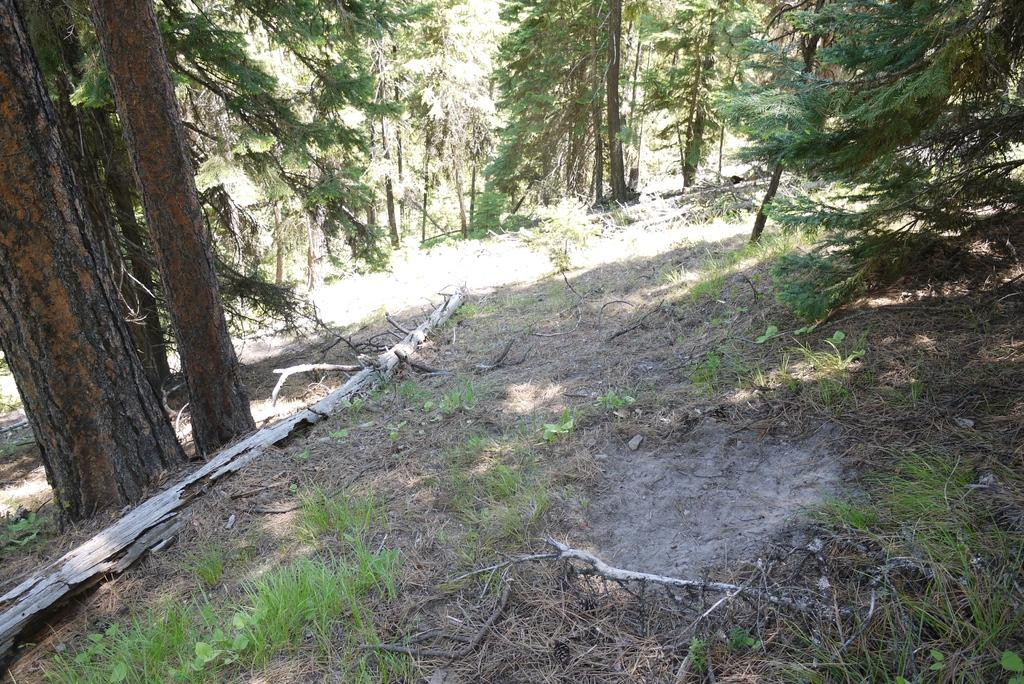What type of vegetation is on the left side of the image? There are trees and grass on the left side of the image. What is located on the left side of the image besides the vegetation? There is a wood on the left side of the image. What type of ground cover is present on both sides of the image? There is grass on the ground on both the left and right sides of the image. What is present on the right side of the image? There is ash on the right side of the image. What type of vegetation is on the right side of the image? There are trees on the right side of the image. What is visible in the background of the image? There are trees in the background of the image. Where is the book placed on the tray in the image? There is no tray or book present in the image. What type of zipper can be seen on the trees in the image? There are no zippers present on the trees in the image; they are natural vegetation. 